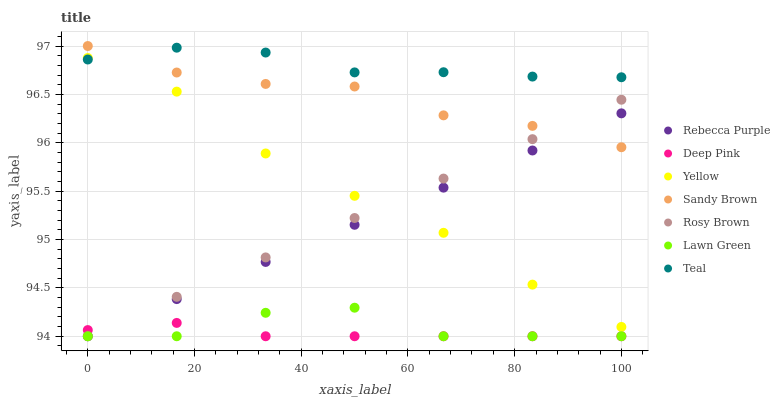Does Deep Pink have the minimum area under the curve?
Answer yes or no. Yes. Does Teal have the maximum area under the curve?
Answer yes or no. Yes. Does Rosy Brown have the minimum area under the curve?
Answer yes or no. No. Does Rosy Brown have the maximum area under the curve?
Answer yes or no. No. Is Rosy Brown the smoothest?
Answer yes or no. Yes. Is Lawn Green the roughest?
Answer yes or no. Yes. Is Deep Pink the smoothest?
Answer yes or no. No. Is Deep Pink the roughest?
Answer yes or no. No. Does Lawn Green have the lowest value?
Answer yes or no. Yes. Does Yellow have the lowest value?
Answer yes or no. No. Does Sandy Brown have the highest value?
Answer yes or no. Yes. Does Rosy Brown have the highest value?
Answer yes or no. No. Is Rosy Brown less than Teal?
Answer yes or no. Yes. Is Teal greater than Rosy Brown?
Answer yes or no. Yes. Does Teal intersect Yellow?
Answer yes or no. Yes. Is Teal less than Yellow?
Answer yes or no. No. Is Teal greater than Yellow?
Answer yes or no. No. Does Rosy Brown intersect Teal?
Answer yes or no. No. 